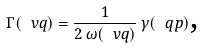<formula> <loc_0><loc_0><loc_500><loc_500>\Gamma ( \ v q ) = \frac { 1 } { 2 \, \omega ( \ v q ) } \, \gamma ( \ q p ) \text  ,</formula> 